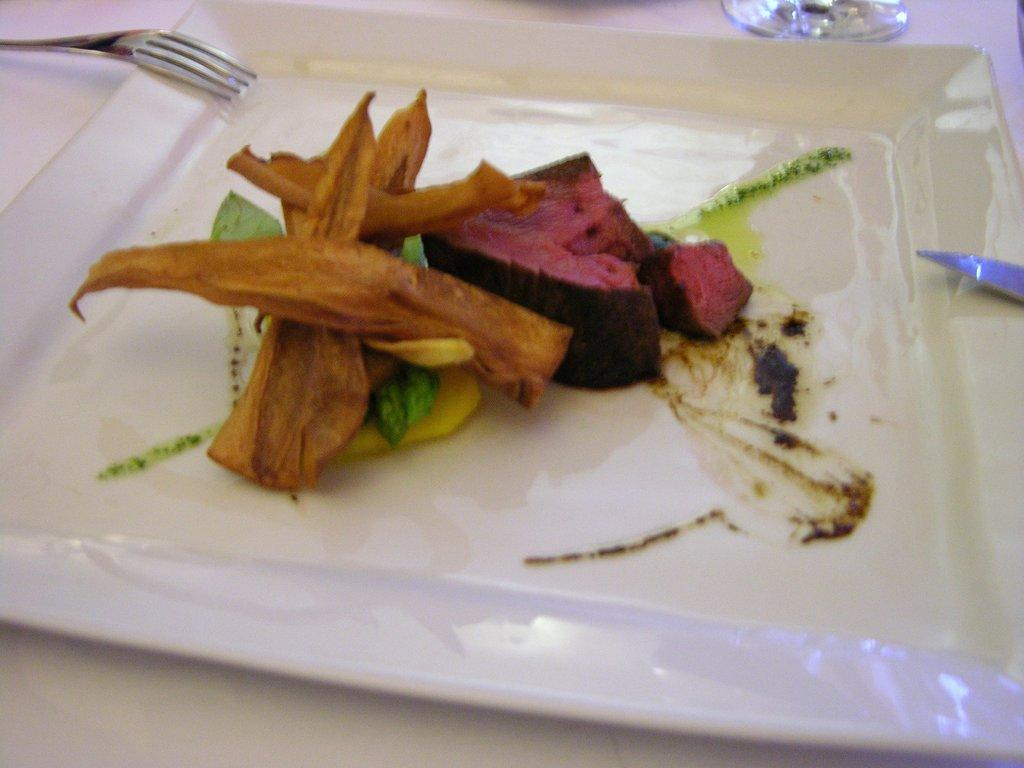What is the color of the surface in the image? The surface in the image is white. What is placed on the white surface? There is a plate on the white surface. What can be found on the plate? There are food items on the plate. What utensils are present in the image? There is a fork and a knife in the image. What is located behind the plate? There is an object behind the plate. Is there a protest happening in the image? No, there is no protest depicted in the image. Where is the hall located in the image? There is no hall present in the image. 